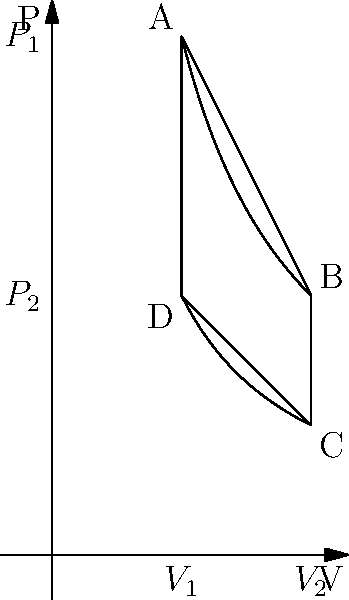A heat engine operates in a cycle shown in the P-V diagram above. The cycle consists of two isothermal processes (AB and CD) and two isochoric processes (BC and DA). If the work done by the gas during the cycle is 2000 J and the heat absorbed during the isothermal expansion AB is 3000 J, calculate the efficiency of the heat engine. To solve this problem, we'll follow these steps:

1) The efficiency of a heat engine is defined as:

   $$ \eta = \frac{W_{net}}{Q_{in}} $$

   where $W_{net}$ is the net work done by the engine and $Q_{in}$ is the heat absorbed by the engine.

2) We're given that the work done by the gas during the cycle (which is equal to $W_{net}$) is 2000 J.

3) We're also given that the heat absorbed during the isothermal expansion AB is 3000 J. This is part of $Q_{in}$.

4) However, we need to consider if there's any other heat input. In a cycle like this:
   - AB: Isothermal expansion (heat is absorbed)
   - BC: Isochoric cooling (heat is released)
   - CD: Isothermal compression (heat is released)
   - DA: Isochoric heating (heat is absorbed)

5) The only other heat input is during the isochoric process DA. However, this heat is exactly equal to the heat released during BC (because the change in internal energy is the same for both processes, just in opposite directions).

6) Therefore, the total heat input $Q_{in}$ is just the heat absorbed during AB, which is 3000 J.

7) Now we can calculate the efficiency:

   $$ \eta = \frac{W_{net}}{Q_{in}} = \frac{2000 \text{ J}}{3000 \text{ J}} = \frac{2}{3} = 0.6667 $$

8) Converting to a percentage:

   $$ \eta = 0.6667 \times 100\% = 66.67\% $$
Answer: 66.67% 